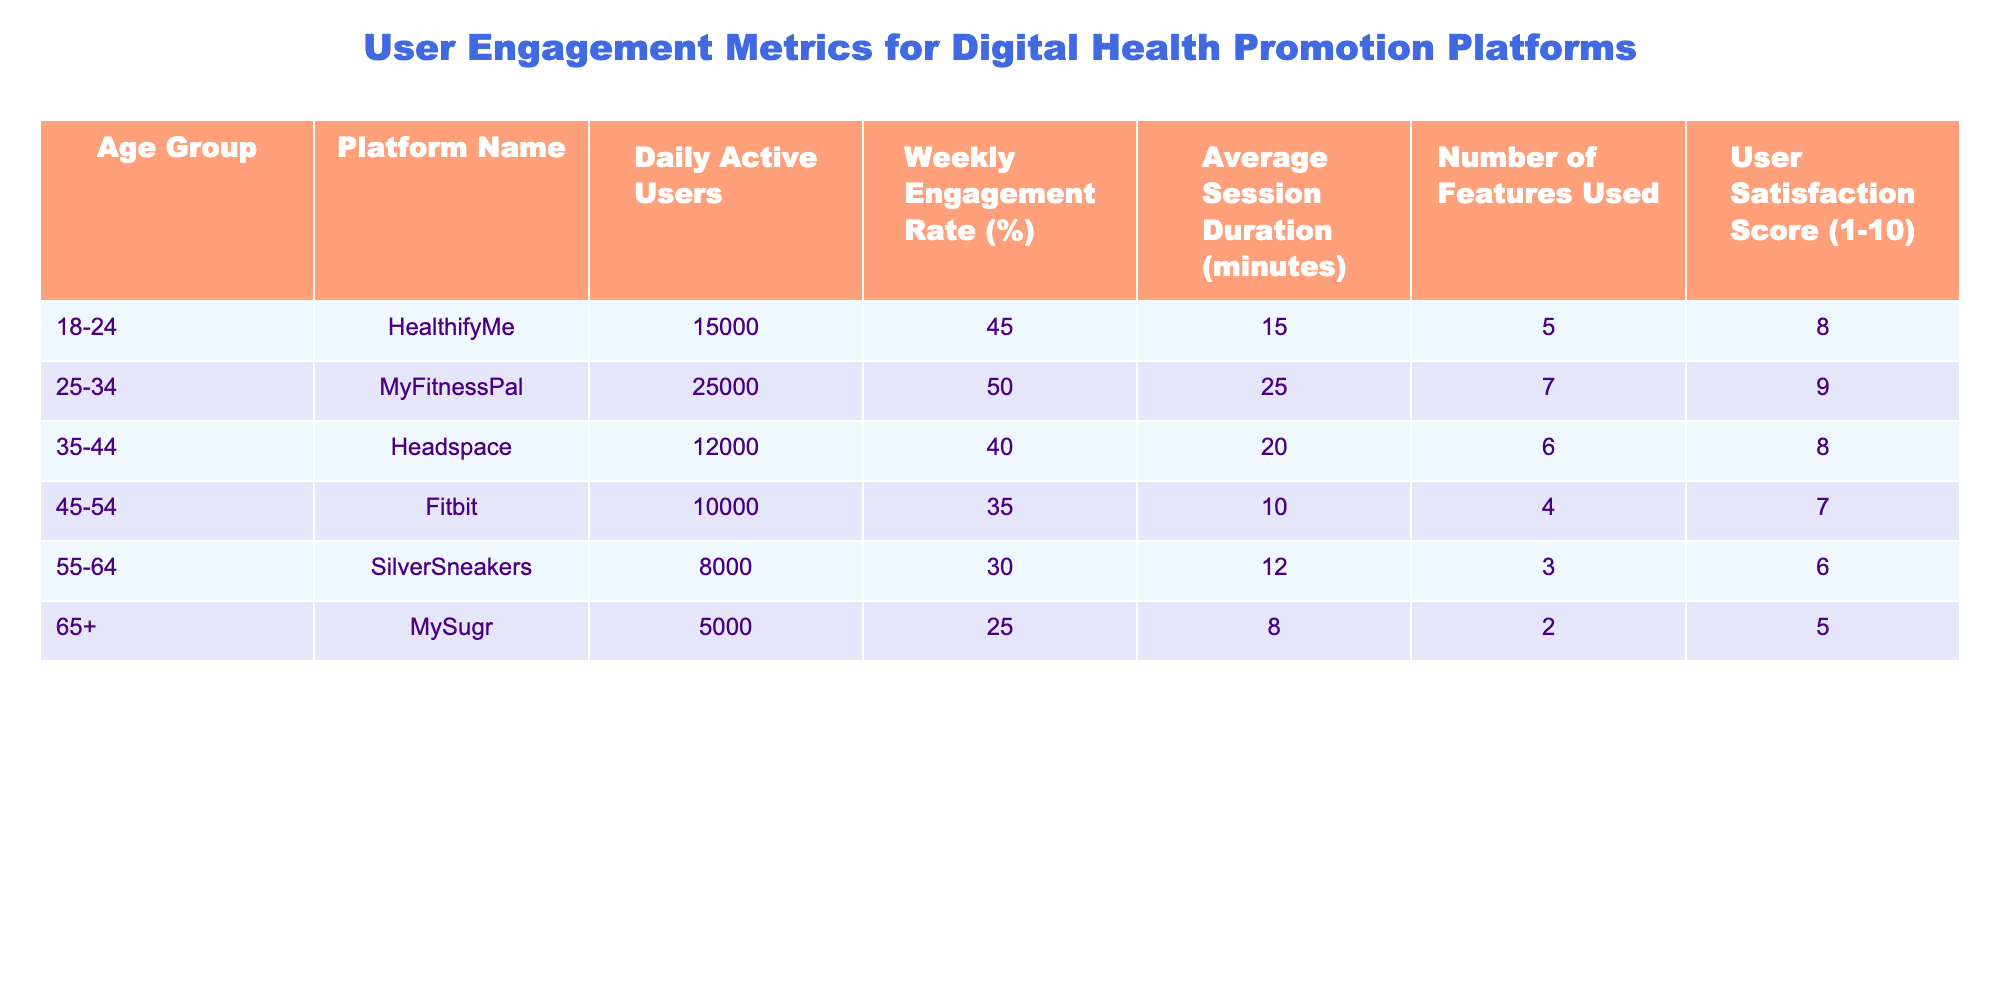What is the user satisfaction score for the 35-44 age group? The user satisfaction score for the 35-44 age group in the table is provided directly under the User Satisfaction Score column where it states 8.
Answer: 8 Which platform has the highest weekly engagement rate and what is that rate? From the table, the platform with the highest weekly engagement rate is MyFitnessPal, with a rate of 50%.
Answer: 50% How many average session minutes does the 45-54 age group spend on their platform? The table indicates that the 45-54 age group has an average session duration of 10 minutes, which is listed under the Average Session Duration column.
Answer: 10 minutes What is the total number of features used by the 18-24 and 25-34 age groups combined? For the 18-24 age group, the number of features used is 5, and for the 25-34 age group, it is 7. When combined, 5 + 7 equals 12 features.
Answer: 12 Is the number of daily active users higher among the 25-34 age group compared to the 35-44 age group? The table shows that the 25-34 age group has 25,000 daily active users, while the 35-44 age group has only 12,000. Therefore, it is true that the 25-34 age group has more daily active users.
Answer: Yes What average session duration would you expect if you averaged the 18-24 and 55-64 age groups? The average session duration for the 18-24 group is 15 minutes, while for the 55-64 group, it is 12 minutes. To find the average, (15 + 12) / 2 equals 13.5 minutes.
Answer: 13.5 minutes Which age group has the lowest user satisfaction score, and what is that score? According to the table, the 65+ age group has the lowest user satisfaction score, which is listed as 5.
Answer: 5 What is the difference in daily active users between the 25-34 and 45-54 age groups? The daily active users for the 25-34 age group is 25,000, while the 45-54 age group is 10,000. The difference is calculated as 25,000 - 10,000, which equals 15,000.
Answer: 15,000 Has the number of features used increased or decreased from the 55-64 to the 45-54 age group? The 55-64 age group uses 3 features, while the 45-54 age group uses 4. This indicates an increase in the number of features used.
Answer: Increased 